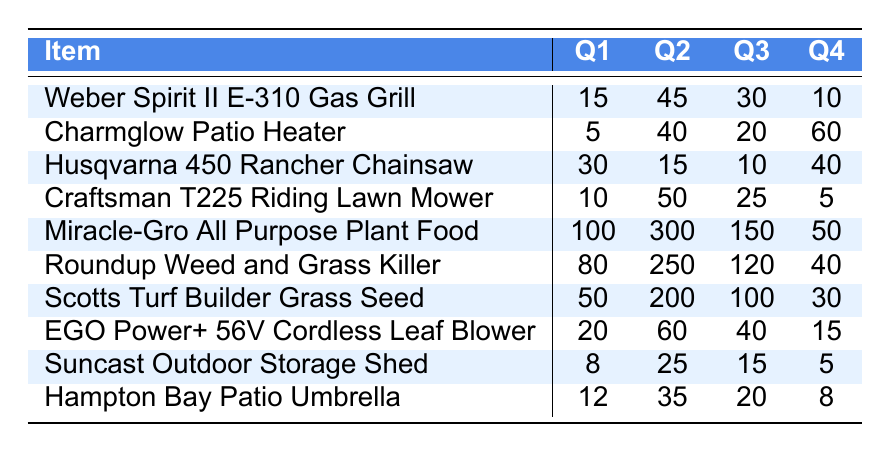What is the inventory level of the Weber Spirit II E-310 Gas Grill in Q3? The table shows the inventory levels for each item by quarter. For the Weber Spirit II E-310 Gas Grill, the inventory level in Q3 is listed under the Q3 column. It is 30.
Answer: 30 Which item has the highest inventory level in Q2? To find the highest inventory level in Q2, we can look down the Q2 column and compare the values: 45, 40, 15, 50, 300, 250, 200, 60, 25, and 35. The highest is 300 for the Miracle-Gro All Purpose Plant Food.
Answer: Miracle-Gro All Purpose Plant Food How much more inventory is there for Roundup Weed and Grass Killer in Q2 compared to Q4? We compare the inventory levels for Roundup Weed and Grass Killer in Q2 (250) and Q4 (40). The difference is 250 - 40 = 210.
Answer: 210 What is the total inventory of the Craftsman T225 Riding Lawn Mower across all quarters? To find the total inventory across all quarters for the Craftsman T225 Riding Lawn Mower, add the values from each quarter: 10 (Q1) + 50 (Q2) + 25 (Q3) + 5 (Q4) = 90.
Answer: 90 Is the inventory level of the Charmglow Patio Heater in Q4 greater than that in Q1? The inventory level for the Charmglow Patio Heater in Q4 is 60, while in Q1 it is 5. Since 60 is greater than 5, the answer is yes.
Answer: Yes What is the average inventory level for all items in Q1? To calculate the average for Q1, sum the inventory levels: 15 + 5 + 30 + 10 + 100 + 80 + 50 + 20 + 8 + 12 = 310. Then divide by the number of items (10). The average is 310 / 10 = 31.
Answer: 31 Which item had the largest decrease in inventory from Q1 to Q4? To find the largest decrease, we calculate the difference for each item from Q1 to Q4: Weber Spirit II E-310: 15 - 10 = 5, Charmglow: 5 - 60 = -55, Husqvarna: 30 - 40 = -10, Craftsman: 10 - 5 = 5, Miracle-Gro: 100 - 50 = 50, Roundup: 80 - 40 = 40, Scotts: 50 - 30 = 20, EGO: 20 - 15 = 5, Suncast: 8 - 5 = 3, Hampton: 12 - 8 = 4. The largest decrease is 55 for Charmglow Patio Heater.
Answer: Charmglow Patio Heater How many items have an inventory level of more than 200 in Q2? Looking at the Q2 column, the items with inventory levels of more than 200 are: Miracle-Gro (300) and Roundup (250). Thus, there are 2 items.
Answer: 2 What is the total inventory for seasonal outdoor items in Q3? We sum the inventory levels for all items in Q3: 30 (Weber) + 20 (Charmglow) + 10 (Husqvarna) + 25 (Craftsman) + 150 (Miracle-Gro) + 120 (Roundup) + 100 (Scotts) + 40 (EGO) + 15 (Suncast) + 20 (Hampton) = 630.
Answer: 630 In which quarter did the Suncast Outdoor Storage Shed have its highest inventory level? The inventory levels for Suncast are: Q1: 8, Q2: 25, Q3: 15, and Q4: 5. The highest inventory level is 25 in Q2.
Answer: Q2 